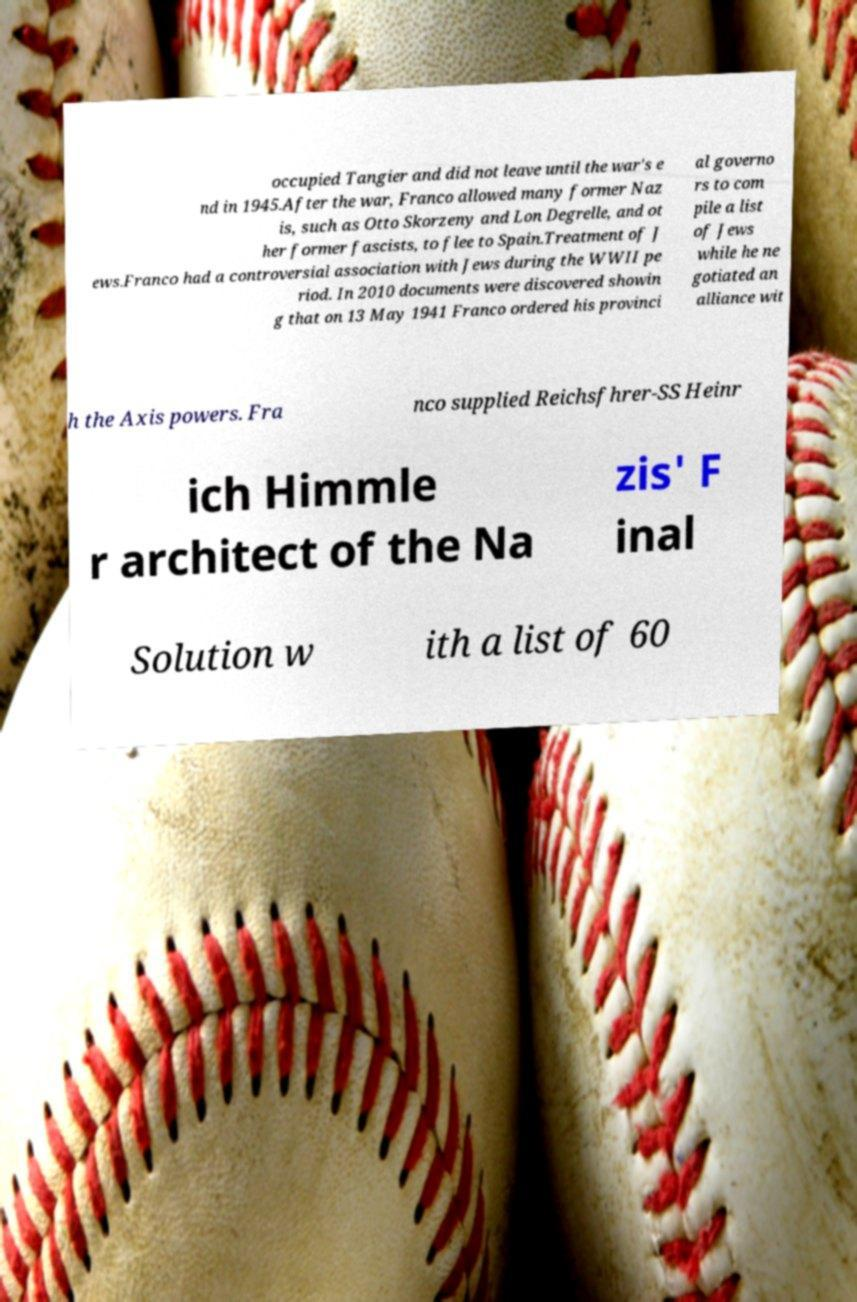Can you accurately transcribe the text from the provided image for me? occupied Tangier and did not leave until the war's e nd in 1945.After the war, Franco allowed many former Naz is, such as Otto Skorzeny and Lon Degrelle, and ot her former fascists, to flee to Spain.Treatment of J ews.Franco had a controversial association with Jews during the WWII pe riod. In 2010 documents were discovered showin g that on 13 May 1941 Franco ordered his provinci al governo rs to com pile a list of Jews while he ne gotiated an alliance wit h the Axis powers. Fra nco supplied Reichsfhrer-SS Heinr ich Himmle r architect of the Na zis' F inal Solution w ith a list of 60 